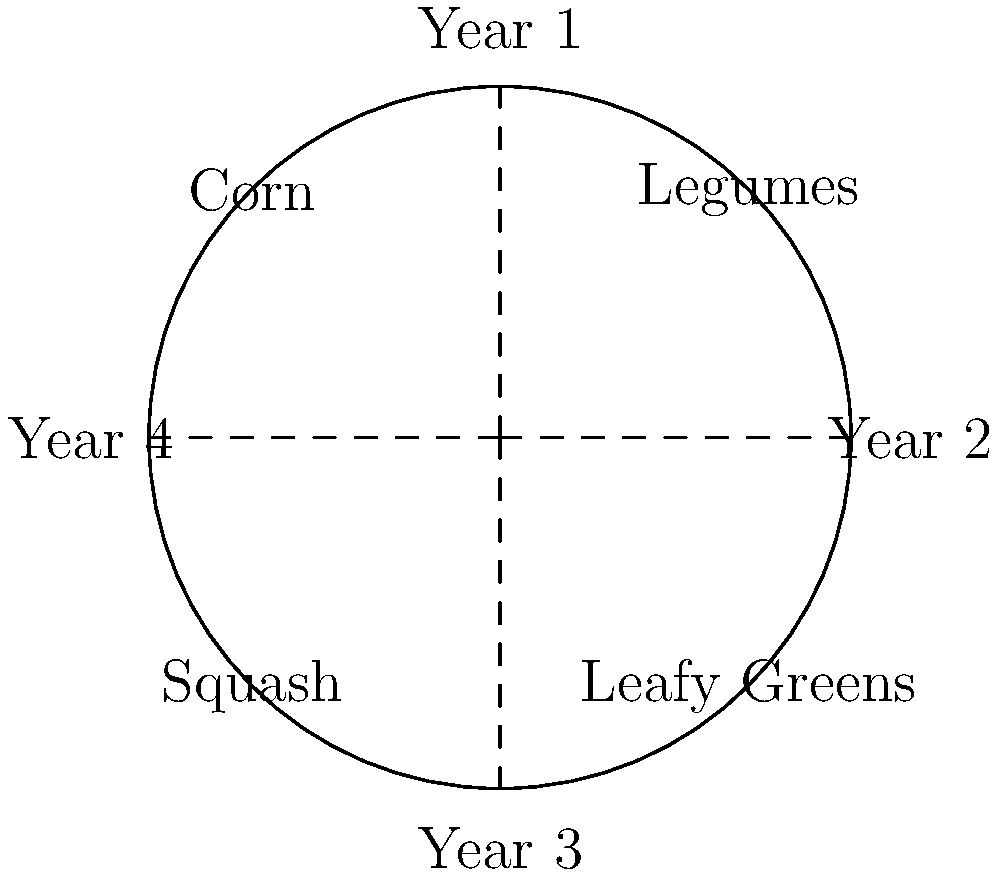The circular diagram shows a 4-year crop rotation plan for an organic farm. If the farm started with legumes in the first year, which crop would be planted in the same field in the third year of the rotation cycle? To determine the crop planted in the third year, we need to follow the rotation pattern shown in the diagram:

1. The diagram is divided into four equal sections, representing a 4-year rotation cycle.
2. The crops are arranged in a clockwise direction: Legumes, Corn, Squash, and Leafy Greens.
3. We start with Legumes in Year 1.
4. Following the clockwise rotation:
   - Year 1: Legumes
   - Year 2: Corn
   - Year 3: Squash
   - Year 4: Leafy Greens
5. Therefore, in the third year of the rotation cycle, Squash would be planted in the same field where Legumes were grown in the first year.

This rotation pattern helps maintain soil health, manage pests and diseases, and optimize nutrient cycling, which are crucial for organic farming and sustainability.
Answer: Squash 